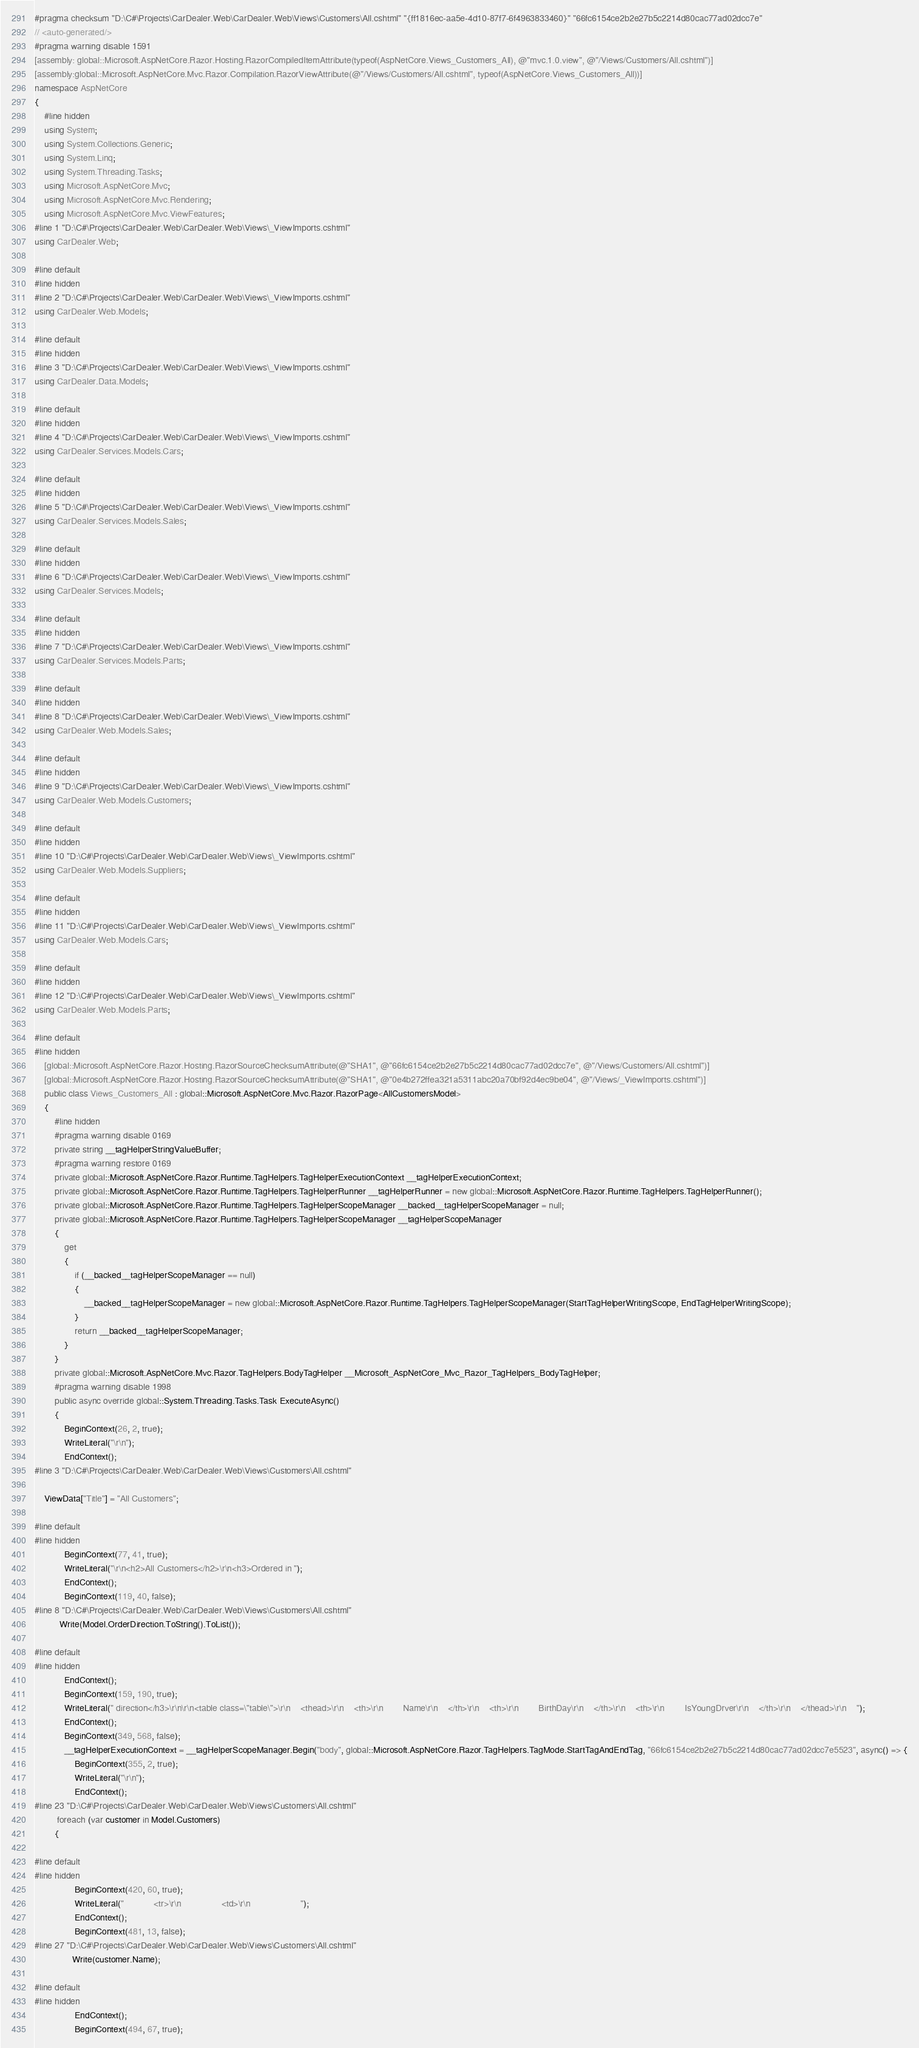<code> <loc_0><loc_0><loc_500><loc_500><_C#_>#pragma checksum "D:\C#\Projects\CarDealer.Web\CarDealer.Web\Views\Customers\All.cshtml" "{ff1816ec-aa5e-4d10-87f7-6f4963833460}" "66fc6154ce2b2e27b5c2214d80cac77ad02dcc7e"
// <auto-generated/>
#pragma warning disable 1591
[assembly: global::Microsoft.AspNetCore.Razor.Hosting.RazorCompiledItemAttribute(typeof(AspNetCore.Views_Customers_All), @"mvc.1.0.view", @"/Views/Customers/All.cshtml")]
[assembly:global::Microsoft.AspNetCore.Mvc.Razor.Compilation.RazorViewAttribute(@"/Views/Customers/All.cshtml", typeof(AspNetCore.Views_Customers_All))]
namespace AspNetCore
{
    #line hidden
    using System;
    using System.Collections.Generic;
    using System.Linq;
    using System.Threading.Tasks;
    using Microsoft.AspNetCore.Mvc;
    using Microsoft.AspNetCore.Mvc.Rendering;
    using Microsoft.AspNetCore.Mvc.ViewFeatures;
#line 1 "D:\C#\Projects\CarDealer.Web\CarDealer.Web\Views\_ViewImports.cshtml"
using CarDealer.Web;

#line default
#line hidden
#line 2 "D:\C#\Projects\CarDealer.Web\CarDealer.Web\Views\_ViewImports.cshtml"
using CarDealer.Web.Models;

#line default
#line hidden
#line 3 "D:\C#\Projects\CarDealer.Web\CarDealer.Web\Views\_ViewImports.cshtml"
using CarDealer.Data.Models;

#line default
#line hidden
#line 4 "D:\C#\Projects\CarDealer.Web\CarDealer.Web\Views\_ViewImports.cshtml"
using CarDealer.Services.Models.Cars;

#line default
#line hidden
#line 5 "D:\C#\Projects\CarDealer.Web\CarDealer.Web\Views\_ViewImports.cshtml"
using CarDealer.Services.Models.Sales;

#line default
#line hidden
#line 6 "D:\C#\Projects\CarDealer.Web\CarDealer.Web\Views\_ViewImports.cshtml"
using CarDealer.Services.Models;

#line default
#line hidden
#line 7 "D:\C#\Projects\CarDealer.Web\CarDealer.Web\Views\_ViewImports.cshtml"
using CarDealer.Services.Models.Parts;

#line default
#line hidden
#line 8 "D:\C#\Projects\CarDealer.Web\CarDealer.Web\Views\_ViewImports.cshtml"
using CarDealer.Web.Models.Sales;

#line default
#line hidden
#line 9 "D:\C#\Projects\CarDealer.Web\CarDealer.Web\Views\_ViewImports.cshtml"
using CarDealer.Web.Models.Customers;

#line default
#line hidden
#line 10 "D:\C#\Projects\CarDealer.Web\CarDealer.Web\Views\_ViewImports.cshtml"
using CarDealer.Web.Models.Suppliers;

#line default
#line hidden
#line 11 "D:\C#\Projects\CarDealer.Web\CarDealer.Web\Views\_ViewImports.cshtml"
using CarDealer.Web.Models.Cars;

#line default
#line hidden
#line 12 "D:\C#\Projects\CarDealer.Web\CarDealer.Web\Views\_ViewImports.cshtml"
using CarDealer.Web.Models.Parts;

#line default
#line hidden
    [global::Microsoft.AspNetCore.Razor.Hosting.RazorSourceChecksumAttribute(@"SHA1", @"66fc6154ce2b2e27b5c2214d80cac77ad02dcc7e", @"/Views/Customers/All.cshtml")]
    [global::Microsoft.AspNetCore.Razor.Hosting.RazorSourceChecksumAttribute(@"SHA1", @"0e4b272ffea321a5311abc20a70bf92d4ec9be04", @"/Views/_ViewImports.cshtml")]
    public class Views_Customers_All : global::Microsoft.AspNetCore.Mvc.Razor.RazorPage<AllCustomersModel>
    {
        #line hidden
        #pragma warning disable 0169
        private string __tagHelperStringValueBuffer;
        #pragma warning restore 0169
        private global::Microsoft.AspNetCore.Razor.Runtime.TagHelpers.TagHelperExecutionContext __tagHelperExecutionContext;
        private global::Microsoft.AspNetCore.Razor.Runtime.TagHelpers.TagHelperRunner __tagHelperRunner = new global::Microsoft.AspNetCore.Razor.Runtime.TagHelpers.TagHelperRunner();
        private global::Microsoft.AspNetCore.Razor.Runtime.TagHelpers.TagHelperScopeManager __backed__tagHelperScopeManager = null;
        private global::Microsoft.AspNetCore.Razor.Runtime.TagHelpers.TagHelperScopeManager __tagHelperScopeManager
        {
            get
            {
                if (__backed__tagHelperScopeManager == null)
                {
                    __backed__tagHelperScopeManager = new global::Microsoft.AspNetCore.Razor.Runtime.TagHelpers.TagHelperScopeManager(StartTagHelperWritingScope, EndTagHelperWritingScope);
                }
                return __backed__tagHelperScopeManager;
            }
        }
        private global::Microsoft.AspNetCore.Mvc.Razor.TagHelpers.BodyTagHelper __Microsoft_AspNetCore_Mvc_Razor_TagHelpers_BodyTagHelper;
        #pragma warning disable 1998
        public async override global::System.Threading.Tasks.Task ExecuteAsync()
        {
            BeginContext(26, 2, true);
            WriteLiteral("\r\n");
            EndContext();
#line 3 "D:\C#\Projects\CarDealer.Web\CarDealer.Web\Views\Customers\All.cshtml"
  
    ViewData["Title"] = "All Customers";

#line default
#line hidden
            BeginContext(77, 41, true);
            WriteLiteral("\r\n<h2>All Customers</h2>\r\n<h3>Ordered in ");
            EndContext();
            BeginContext(119, 40, false);
#line 8 "D:\C#\Projects\CarDealer.Web\CarDealer.Web\Views\Customers\All.cshtml"
          Write(Model.OrderDirection.ToString().ToList());

#line default
#line hidden
            EndContext();
            BeginContext(159, 190, true);
            WriteLiteral(" direction</h3>\r\n\r\n<table class=\"table\">\r\n    <thead>\r\n    <th>\r\n        Name\r\n    </th>\r\n    <th>\r\n        BirthDay\r\n    </th>\r\n    <th>\r\n        IsYoungDrver\r\n    </th>\r\n    </thead>\r\n    ");
            EndContext();
            BeginContext(349, 568, false);
            __tagHelperExecutionContext = __tagHelperScopeManager.Begin("body", global::Microsoft.AspNetCore.Razor.TagHelpers.TagMode.StartTagAndEndTag, "66fc6154ce2b2e27b5c2214d80cac77ad02dcc7e5523", async() => {
                BeginContext(355, 2, true);
                WriteLiteral("\r\n");
                EndContext();
#line 23 "D:\C#\Projects\CarDealer.Web\CarDealer.Web\Views\Customers\All.cshtml"
         foreach (var customer in Model.Customers)
        {

#line default
#line hidden
                BeginContext(420, 60, true);
                WriteLiteral("            <tr>\r\n                <td>\r\n                    ");
                EndContext();
                BeginContext(481, 13, false);
#line 27 "D:\C#\Projects\CarDealer.Web\CarDealer.Web\Views\Customers\All.cshtml"
               Write(customer.Name);

#line default
#line hidden
                EndContext();
                BeginContext(494, 67, true);</code> 